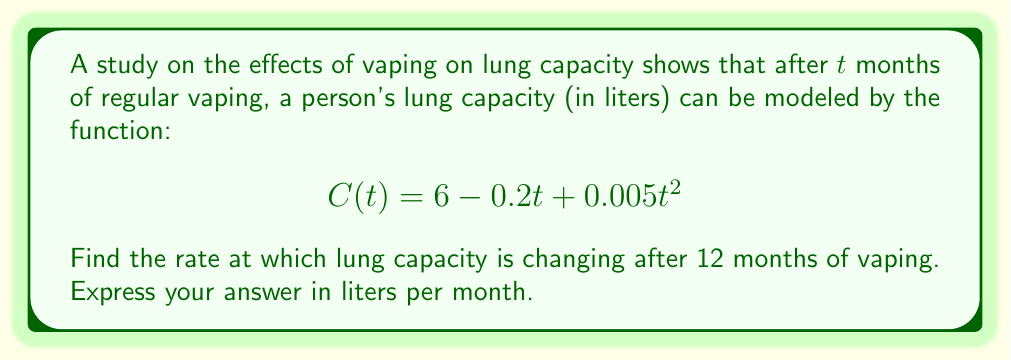Show me your answer to this math problem. To find the rate at which lung capacity is changing, we need to find the derivative of the given function and evaluate it at $t = 12$ months.

1. The given function is:
   $$C(t) = 6 - 0.2t + 0.005t^2$$

2. To find the rate of change, we need to differentiate $C(t)$ with respect to $t$:
   $$\frac{dC}{dt} = -0.2 + 0.01t$$

3. This derivative represents the instantaneous rate of change of lung capacity with respect to time.

4. To find the rate of change after 12 months, we substitute $t = 12$ into the derivative:
   $$\frac{dC}{dt}\bigg|_{t=12} = -0.2 + 0.01(12) = -0.2 + 0.12 = -0.08$$

5. The negative sign indicates that lung capacity is decreasing.
Answer: The rate at which lung capacity is changing after 12 months of vaping is $-0.08$ liters per month. 